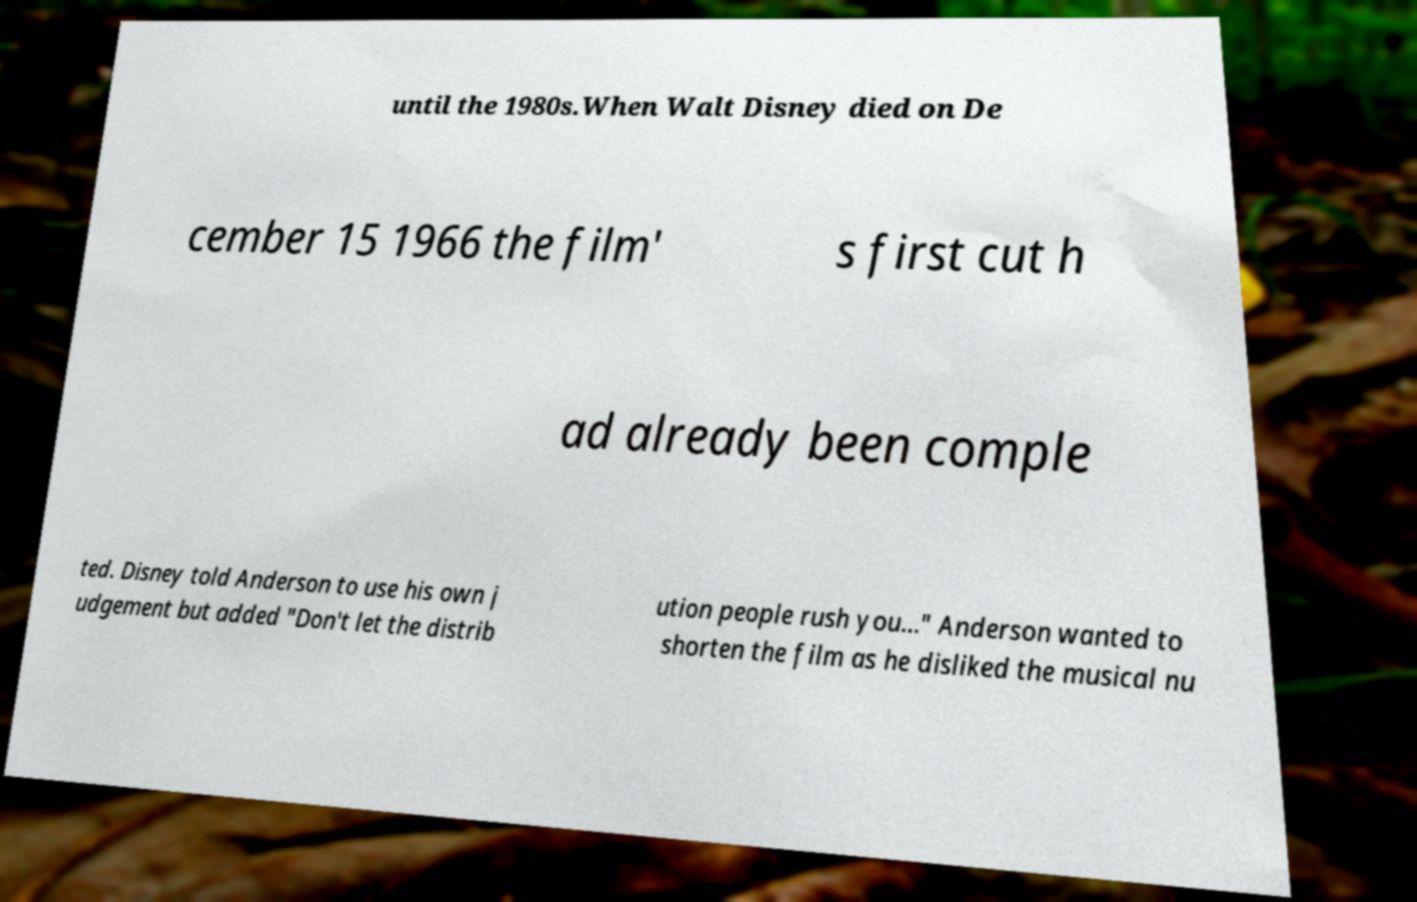Could you assist in decoding the text presented in this image and type it out clearly? until the 1980s.When Walt Disney died on De cember 15 1966 the film' s first cut h ad already been comple ted. Disney told Anderson to use his own j udgement but added "Don't let the distrib ution people rush you..." Anderson wanted to shorten the film as he disliked the musical nu 